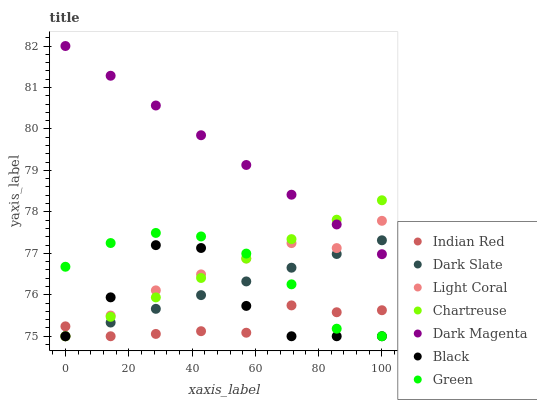Does Indian Red have the minimum area under the curve?
Answer yes or no. Yes. Does Dark Magenta have the maximum area under the curve?
Answer yes or no. Yes. Does Light Coral have the minimum area under the curve?
Answer yes or no. No. Does Light Coral have the maximum area under the curve?
Answer yes or no. No. Is Chartreuse the smoothest?
Answer yes or no. Yes. Is Black the roughest?
Answer yes or no. Yes. Is Light Coral the smoothest?
Answer yes or no. No. Is Light Coral the roughest?
Answer yes or no. No. Does Light Coral have the lowest value?
Answer yes or no. Yes. Does Dark Magenta have the highest value?
Answer yes or no. Yes. Does Light Coral have the highest value?
Answer yes or no. No. Is Black less than Dark Magenta?
Answer yes or no. Yes. Is Dark Magenta greater than Green?
Answer yes or no. Yes. Does Light Coral intersect Dark Magenta?
Answer yes or no. Yes. Is Light Coral less than Dark Magenta?
Answer yes or no. No. Is Light Coral greater than Dark Magenta?
Answer yes or no. No. Does Black intersect Dark Magenta?
Answer yes or no. No. 